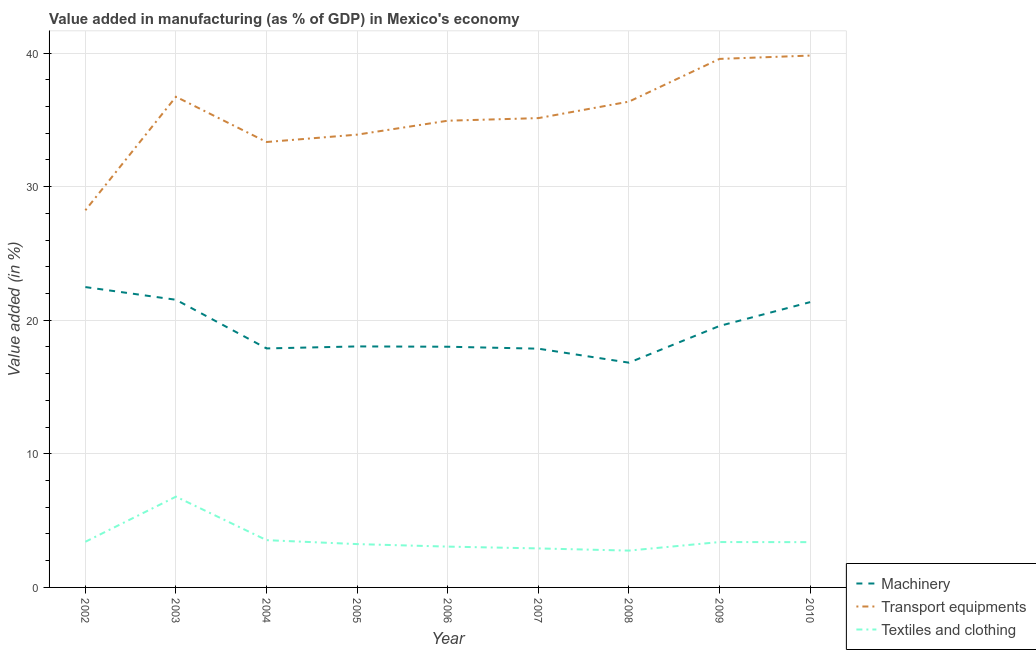How many different coloured lines are there?
Give a very brief answer. 3. What is the value added in manufacturing textile and clothing in 2009?
Give a very brief answer. 3.4. Across all years, what is the maximum value added in manufacturing machinery?
Your answer should be compact. 22.48. Across all years, what is the minimum value added in manufacturing textile and clothing?
Your response must be concise. 2.76. What is the total value added in manufacturing textile and clothing in the graph?
Give a very brief answer. 32.51. What is the difference between the value added in manufacturing transport equipments in 2002 and that in 2009?
Provide a succinct answer. -11.33. What is the difference between the value added in manufacturing transport equipments in 2004 and the value added in manufacturing machinery in 2009?
Offer a very short reply. 13.77. What is the average value added in manufacturing machinery per year?
Give a very brief answer. 19.29. In the year 2007, what is the difference between the value added in manufacturing transport equipments and value added in manufacturing textile and clothing?
Your answer should be compact. 32.21. In how many years, is the value added in manufacturing textile and clothing greater than 28 %?
Offer a very short reply. 0. What is the ratio of the value added in manufacturing machinery in 2005 to that in 2007?
Your answer should be compact. 1.01. Is the value added in manufacturing machinery in 2005 less than that in 2007?
Offer a very short reply. No. Is the difference between the value added in manufacturing machinery in 2003 and 2006 greater than the difference between the value added in manufacturing transport equipments in 2003 and 2006?
Your response must be concise. Yes. What is the difference between the highest and the second highest value added in manufacturing textile and clothing?
Provide a succinct answer. 3.26. What is the difference between the highest and the lowest value added in manufacturing transport equipments?
Make the answer very short. 11.58. Does the value added in manufacturing textile and clothing monotonically increase over the years?
Your answer should be compact. No. Is the value added in manufacturing textile and clothing strictly greater than the value added in manufacturing transport equipments over the years?
Give a very brief answer. No. Is the value added in manufacturing transport equipments strictly less than the value added in manufacturing machinery over the years?
Give a very brief answer. No. How many lines are there?
Offer a very short reply. 3. How many years are there in the graph?
Ensure brevity in your answer.  9. What is the difference between two consecutive major ticks on the Y-axis?
Offer a terse response. 10. Does the graph contain grids?
Your response must be concise. Yes. Where does the legend appear in the graph?
Provide a short and direct response. Bottom right. How are the legend labels stacked?
Your response must be concise. Vertical. What is the title of the graph?
Ensure brevity in your answer.  Value added in manufacturing (as % of GDP) in Mexico's economy. Does "Self-employed" appear as one of the legend labels in the graph?
Provide a short and direct response. No. What is the label or title of the Y-axis?
Your answer should be very brief. Value added (in %). What is the Value added (in %) of Machinery in 2002?
Ensure brevity in your answer.  22.48. What is the Value added (in %) in Transport equipments in 2002?
Your answer should be compact. 28.23. What is the Value added (in %) of Textiles and clothing in 2002?
Offer a terse response. 3.42. What is the Value added (in %) of Machinery in 2003?
Provide a short and direct response. 21.53. What is the Value added (in %) of Transport equipments in 2003?
Offer a very short reply. 36.73. What is the Value added (in %) of Textiles and clothing in 2003?
Your answer should be compact. 6.79. What is the Value added (in %) of Machinery in 2004?
Your answer should be very brief. 17.89. What is the Value added (in %) of Transport equipments in 2004?
Offer a very short reply. 33.34. What is the Value added (in %) in Textiles and clothing in 2004?
Make the answer very short. 3.54. What is the Value added (in %) of Machinery in 2005?
Offer a very short reply. 18.04. What is the Value added (in %) in Transport equipments in 2005?
Your response must be concise. 33.89. What is the Value added (in %) in Textiles and clothing in 2005?
Your response must be concise. 3.24. What is the Value added (in %) of Machinery in 2006?
Offer a terse response. 18.02. What is the Value added (in %) in Transport equipments in 2006?
Make the answer very short. 34.94. What is the Value added (in %) in Textiles and clothing in 2006?
Offer a very short reply. 3.06. What is the Value added (in %) in Machinery in 2007?
Offer a terse response. 17.87. What is the Value added (in %) in Transport equipments in 2007?
Your response must be concise. 35.13. What is the Value added (in %) of Textiles and clothing in 2007?
Provide a short and direct response. 2.92. What is the Value added (in %) in Machinery in 2008?
Offer a very short reply. 16.82. What is the Value added (in %) in Transport equipments in 2008?
Your answer should be very brief. 36.36. What is the Value added (in %) in Textiles and clothing in 2008?
Offer a terse response. 2.76. What is the Value added (in %) of Machinery in 2009?
Provide a short and direct response. 19.57. What is the Value added (in %) of Transport equipments in 2009?
Keep it short and to the point. 39.56. What is the Value added (in %) in Textiles and clothing in 2009?
Your response must be concise. 3.4. What is the Value added (in %) of Machinery in 2010?
Your answer should be compact. 21.36. What is the Value added (in %) of Transport equipments in 2010?
Provide a succinct answer. 39.81. What is the Value added (in %) in Textiles and clothing in 2010?
Provide a short and direct response. 3.39. Across all years, what is the maximum Value added (in %) of Machinery?
Your response must be concise. 22.48. Across all years, what is the maximum Value added (in %) of Transport equipments?
Provide a succinct answer. 39.81. Across all years, what is the maximum Value added (in %) in Textiles and clothing?
Your response must be concise. 6.79. Across all years, what is the minimum Value added (in %) of Machinery?
Provide a short and direct response. 16.82. Across all years, what is the minimum Value added (in %) of Transport equipments?
Provide a short and direct response. 28.23. Across all years, what is the minimum Value added (in %) in Textiles and clothing?
Provide a short and direct response. 2.76. What is the total Value added (in %) in Machinery in the graph?
Offer a terse response. 173.59. What is the total Value added (in %) of Transport equipments in the graph?
Give a very brief answer. 318. What is the total Value added (in %) of Textiles and clothing in the graph?
Your answer should be compact. 32.51. What is the difference between the Value added (in %) in Machinery in 2002 and that in 2003?
Your response must be concise. 0.95. What is the difference between the Value added (in %) of Transport equipments in 2002 and that in 2003?
Make the answer very short. -8.5. What is the difference between the Value added (in %) in Textiles and clothing in 2002 and that in 2003?
Offer a terse response. -3.38. What is the difference between the Value added (in %) of Machinery in 2002 and that in 2004?
Ensure brevity in your answer.  4.59. What is the difference between the Value added (in %) of Transport equipments in 2002 and that in 2004?
Give a very brief answer. -5.11. What is the difference between the Value added (in %) of Textiles and clothing in 2002 and that in 2004?
Give a very brief answer. -0.12. What is the difference between the Value added (in %) of Machinery in 2002 and that in 2005?
Keep it short and to the point. 4.44. What is the difference between the Value added (in %) of Transport equipments in 2002 and that in 2005?
Ensure brevity in your answer.  -5.66. What is the difference between the Value added (in %) in Textiles and clothing in 2002 and that in 2005?
Provide a short and direct response. 0.17. What is the difference between the Value added (in %) in Machinery in 2002 and that in 2006?
Ensure brevity in your answer.  4.47. What is the difference between the Value added (in %) of Transport equipments in 2002 and that in 2006?
Ensure brevity in your answer.  -6.71. What is the difference between the Value added (in %) of Textiles and clothing in 2002 and that in 2006?
Offer a very short reply. 0.36. What is the difference between the Value added (in %) in Machinery in 2002 and that in 2007?
Your answer should be very brief. 4.61. What is the difference between the Value added (in %) in Transport equipments in 2002 and that in 2007?
Your answer should be compact. -6.9. What is the difference between the Value added (in %) in Textiles and clothing in 2002 and that in 2007?
Keep it short and to the point. 0.5. What is the difference between the Value added (in %) in Machinery in 2002 and that in 2008?
Make the answer very short. 5.66. What is the difference between the Value added (in %) of Transport equipments in 2002 and that in 2008?
Provide a succinct answer. -8.13. What is the difference between the Value added (in %) of Textiles and clothing in 2002 and that in 2008?
Make the answer very short. 0.66. What is the difference between the Value added (in %) of Machinery in 2002 and that in 2009?
Keep it short and to the point. 2.91. What is the difference between the Value added (in %) in Transport equipments in 2002 and that in 2009?
Give a very brief answer. -11.33. What is the difference between the Value added (in %) of Textiles and clothing in 2002 and that in 2009?
Provide a short and direct response. 0.02. What is the difference between the Value added (in %) in Machinery in 2002 and that in 2010?
Make the answer very short. 1.13. What is the difference between the Value added (in %) of Transport equipments in 2002 and that in 2010?
Offer a very short reply. -11.58. What is the difference between the Value added (in %) of Textiles and clothing in 2002 and that in 2010?
Make the answer very short. 0.03. What is the difference between the Value added (in %) in Machinery in 2003 and that in 2004?
Provide a succinct answer. 3.64. What is the difference between the Value added (in %) of Transport equipments in 2003 and that in 2004?
Your answer should be very brief. 3.39. What is the difference between the Value added (in %) in Textiles and clothing in 2003 and that in 2004?
Provide a short and direct response. 3.26. What is the difference between the Value added (in %) in Machinery in 2003 and that in 2005?
Your answer should be compact. 3.49. What is the difference between the Value added (in %) of Transport equipments in 2003 and that in 2005?
Your response must be concise. 2.84. What is the difference between the Value added (in %) in Textiles and clothing in 2003 and that in 2005?
Give a very brief answer. 3.55. What is the difference between the Value added (in %) in Machinery in 2003 and that in 2006?
Your answer should be very brief. 3.52. What is the difference between the Value added (in %) of Transport equipments in 2003 and that in 2006?
Keep it short and to the point. 1.79. What is the difference between the Value added (in %) of Textiles and clothing in 2003 and that in 2006?
Keep it short and to the point. 3.74. What is the difference between the Value added (in %) in Machinery in 2003 and that in 2007?
Offer a terse response. 3.66. What is the difference between the Value added (in %) in Transport equipments in 2003 and that in 2007?
Your response must be concise. 1.6. What is the difference between the Value added (in %) in Textiles and clothing in 2003 and that in 2007?
Provide a succinct answer. 3.87. What is the difference between the Value added (in %) in Machinery in 2003 and that in 2008?
Make the answer very short. 4.71. What is the difference between the Value added (in %) of Transport equipments in 2003 and that in 2008?
Make the answer very short. 0.37. What is the difference between the Value added (in %) in Textiles and clothing in 2003 and that in 2008?
Offer a very short reply. 4.04. What is the difference between the Value added (in %) in Machinery in 2003 and that in 2009?
Offer a terse response. 1.96. What is the difference between the Value added (in %) of Transport equipments in 2003 and that in 2009?
Offer a terse response. -2.83. What is the difference between the Value added (in %) of Textiles and clothing in 2003 and that in 2009?
Keep it short and to the point. 3.4. What is the difference between the Value added (in %) of Machinery in 2003 and that in 2010?
Provide a succinct answer. 0.18. What is the difference between the Value added (in %) in Transport equipments in 2003 and that in 2010?
Your answer should be compact. -3.08. What is the difference between the Value added (in %) of Textiles and clothing in 2003 and that in 2010?
Ensure brevity in your answer.  3.4. What is the difference between the Value added (in %) in Machinery in 2004 and that in 2005?
Make the answer very short. -0.15. What is the difference between the Value added (in %) of Transport equipments in 2004 and that in 2005?
Offer a very short reply. -0.55. What is the difference between the Value added (in %) of Textiles and clothing in 2004 and that in 2005?
Keep it short and to the point. 0.3. What is the difference between the Value added (in %) in Machinery in 2004 and that in 2006?
Your response must be concise. -0.13. What is the difference between the Value added (in %) in Transport equipments in 2004 and that in 2006?
Provide a succinct answer. -1.59. What is the difference between the Value added (in %) in Textiles and clothing in 2004 and that in 2006?
Provide a succinct answer. 0.48. What is the difference between the Value added (in %) in Machinery in 2004 and that in 2007?
Your answer should be compact. 0.02. What is the difference between the Value added (in %) of Transport equipments in 2004 and that in 2007?
Your answer should be very brief. -1.79. What is the difference between the Value added (in %) in Textiles and clothing in 2004 and that in 2007?
Offer a terse response. 0.62. What is the difference between the Value added (in %) in Machinery in 2004 and that in 2008?
Provide a short and direct response. 1.07. What is the difference between the Value added (in %) of Transport equipments in 2004 and that in 2008?
Your answer should be very brief. -3.02. What is the difference between the Value added (in %) in Textiles and clothing in 2004 and that in 2008?
Provide a short and direct response. 0.78. What is the difference between the Value added (in %) of Machinery in 2004 and that in 2009?
Provide a succinct answer. -1.68. What is the difference between the Value added (in %) of Transport equipments in 2004 and that in 2009?
Keep it short and to the point. -6.22. What is the difference between the Value added (in %) of Textiles and clothing in 2004 and that in 2009?
Provide a short and direct response. 0.14. What is the difference between the Value added (in %) in Machinery in 2004 and that in 2010?
Give a very brief answer. -3.47. What is the difference between the Value added (in %) of Transport equipments in 2004 and that in 2010?
Your answer should be compact. -6.47. What is the difference between the Value added (in %) in Textiles and clothing in 2004 and that in 2010?
Offer a terse response. 0.15. What is the difference between the Value added (in %) in Machinery in 2005 and that in 2006?
Keep it short and to the point. 0.02. What is the difference between the Value added (in %) in Transport equipments in 2005 and that in 2006?
Your response must be concise. -1.04. What is the difference between the Value added (in %) in Textiles and clothing in 2005 and that in 2006?
Offer a terse response. 0.19. What is the difference between the Value added (in %) in Machinery in 2005 and that in 2007?
Ensure brevity in your answer.  0.17. What is the difference between the Value added (in %) in Transport equipments in 2005 and that in 2007?
Provide a succinct answer. -1.24. What is the difference between the Value added (in %) of Textiles and clothing in 2005 and that in 2007?
Keep it short and to the point. 0.32. What is the difference between the Value added (in %) in Machinery in 2005 and that in 2008?
Offer a very short reply. 1.22. What is the difference between the Value added (in %) of Transport equipments in 2005 and that in 2008?
Ensure brevity in your answer.  -2.47. What is the difference between the Value added (in %) in Textiles and clothing in 2005 and that in 2008?
Provide a succinct answer. 0.49. What is the difference between the Value added (in %) in Machinery in 2005 and that in 2009?
Provide a succinct answer. -1.53. What is the difference between the Value added (in %) in Transport equipments in 2005 and that in 2009?
Keep it short and to the point. -5.67. What is the difference between the Value added (in %) in Textiles and clothing in 2005 and that in 2009?
Ensure brevity in your answer.  -0.15. What is the difference between the Value added (in %) of Machinery in 2005 and that in 2010?
Offer a terse response. -3.32. What is the difference between the Value added (in %) of Transport equipments in 2005 and that in 2010?
Provide a short and direct response. -5.92. What is the difference between the Value added (in %) in Textiles and clothing in 2005 and that in 2010?
Keep it short and to the point. -0.15. What is the difference between the Value added (in %) in Machinery in 2006 and that in 2007?
Provide a succinct answer. 0.15. What is the difference between the Value added (in %) in Transport equipments in 2006 and that in 2007?
Your answer should be very brief. -0.2. What is the difference between the Value added (in %) in Textiles and clothing in 2006 and that in 2007?
Your answer should be very brief. 0.14. What is the difference between the Value added (in %) in Machinery in 2006 and that in 2008?
Provide a short and direct response. 1.19. What is the difference between the Value added (in %) in Transport equipments in 2006 and that in 2008?
Provide a short and direct response. -1.43. What is the difference between the Value added (in %) of Textiles and clothing in 2006 and that in 2008?
Your response must be concise. 0.3. What is the difference between the Value added (in %) in Machinery in 2006 and that in 2009?
Your response must be concise. -1.56. What is the difference between the Value added (in %) in Transport equipments in 2006 and that in 2009?
Your answer should be very brief. -4.63. What is the difference between the Value added (in %) of Textiles and clothing in 2006 and that in 2009?
Offer a terse response. -0.34. What is the difference between the Value added (in %) of Machinery in 2006 and that in 2010?
Offer a very short reply. -3.34. What is the difference between the Value added (in %) in Transport equipments in 2006 and that in 2010?
Make the answer very short. -4.88. What is the difference between the Value added (in %) in Textiles and clothing in 2006 and that in 2010?
Provide a succinct answer. -0.33. What is the difference between the Value added (in %) in Machinery in 2007 and that in 2008?
Keep it short and to the point. 1.05. What is the difference between the Value added (in %) of Transport equipments in 2007 and that in 2008?
Offer a very short reply. -1.23. What is the difference between the Value added (in %) of Textiles and clothing in 2007 and that in 2008?
Make the answer very short. 0.16. What is the difference between the Value added (in %) in Machinery in 2007 and that in 2009?
Keep it short and to the point. -1.7. What is the difference between the Value added (in %) in Transport equipments in 2007 and that in 2009?
Your answer should be very brief. -4.43. What is the difference between the Value added (in %) of Textiles and clothing in 2007 and that in 2009?
Offer a terse response. -0.48. What is the difference between the Value added (in %) of Machinery in 2007 and that in 2010?
Your answer should be very brief. -3.48. What is the difference between the Value added (in %) in Transport equipments in 2007 and that in 2010?
Ensure brevity in your answer.  -4.68. What is the difference between the Value added (in %) in Textiles and clothing in 2007 and that in 2010?
Provide a short and direct response. -0.47. What is the difference between the Value added (in %) of Machinery in 2008 and that in 2009?
Make the answer very short. -2.75. What is the difference between the Value added (in %) in Transport equipments in 2008 and that in 2009?
Ensure brevity in your answer.  -3.2. What is the difference between the Value added (in %) of Textiles and clothing in 2008 and that in 2009?
Make the answer very short. -0.64. What is the difference between the Value added (in %) of Machinery in 2008 and that in 2010?
Offer a terse response. -4.53. What is the difference between the Value added (in %) in Transport equipments in 2008 and that in 2010?
Provide a succinct answer. -3.45. What is the difference between the Value added (in %) of Textiles and clothing in 2008 and that in 2010?
Your answer should be compact. -0.63. What is the difference between the Value added (in %) of Machinery in 2009 and that in 2010?
Provide a short and direct response. -1.78. What is the difference between the Value added (in %) in Transport equipments in 2009 and that in 2010?
Offer a very short reply. -0.25. What is the difference between the Value added (in %) of Textiles and clothing in 2009 and that in 2010?
Ensure brevity in your answer.  0.01. What is the difference between the Value added (in %) in Machinery in 2002 and the Value added (in %) in Transport equipments in 2003?
Provide a succinct answer. -14.25. What is the difference between the Value added (in %) in Machinery in 2002 and the Value added (in %) in Textiles and clothing in 2003?
Provide a short and direct response. 15.69. What is the difference between the Value added (in %) in Transport equipments in 2002 and the Value added (in %) in Textiles and clothing in 2003?
Your answer should be compact. 21.44. What is the difference between the Value added (in %) of Machinery in 2002 and the Value added (in %) of Transport equipments in 2004?
Keep it short and to the point. -10.86. What is the difference between the Value added (in %) of Machinery in 2002 and the Value added (in %) of Textiles and clothing in 2004?
Ensure brevity in your answer.  18.94. What is the difference between the Value added (in %) of Transport equipments in 2002 and the Value added (in %) of Textiles and clothing in 2004?
Make the answer very short. 24.69. What is the difference between the Value added (in %) of Machinery in 2002 and the Value added (in %) of Transport equipments in 2005?
Make the answer very short. -11.41. What is the difference between the Value added (in %) of Machinery in 2002 and the Value added (in %) of Textiles and clothing in 2005?
Give a very brief answer. 19.24. What is the difference between the Value added (in %) of Transport equipments in 2002 and the Value added (in %) of Textiles and clothing in 2005?
Provide a succinct answer. 24.99. What is the difference between the Value added (in %) of Machinery in 2002 and the Value added (in %) of Transport equipments in 2006?
Keep it short and to the point. -12.45. What is the difference between the Value added (in %) of Machinery in 2002 and the Value added (in %) of Textiles and clothing in 2006?
Your answer should be compact. 19.43. What is the difference between the Value added (in %) in Transport equipments in 2002 and the Value added (in %) in Textiles and clothing in 2006?
Provide a succinct answer. 25.18. What is the difference between the Value added (in %) in Machinery in 2002 and the Value added (in %) in Transport equipments in 2007?
Offer a terse response. -12.65. What is the difference between the Value added (in %) in Machinery in 2002 and the Value added (in %) in Textiles and clothing in 2007?
Keep it short and to the point. 19.56. What is the difference between the Value added (in %) in Transport equipments in 2002 and the Value added (in %) in Textiles and clothing in 2007?
Make the answer very short. 25.31. What is the difference between the Value added (in %) in Machinery in 2002 and the Value added (in %) in Transport equipments in 2008?
Keep it short and to the point. -13.88. What is the difference between the Value added (in %) in Machinery in 2002 and the Value added (in %) in Textiles and clothing in 2008?
Offer a very short reply. 19.73. What is the difference between the Value added (in %) in Transport equipments in 2002 and the Value added (in %) in Textiles and clothing in 2008?
Your answer should be compact. 25.47. What is the difference between the Value added (in %) in Machinery in 2002 and the Value added (in %) in Transport equipments in 2009?
Your answer should be very brief. -17.08. What is the difference between the Value added (in %) in Machinery in 2002 and the Value added (in %) in Textiles and clothing in 2009?
Make the answer very short. 19.09. What is the difference between the Value added (in %) of Transport equipments in 2002 and the Value added (in %) of Textiles and clothing in 2009?
Give a very brief answer. 24.83. What is the difference between the Value added (in %) in Machinery in 2002 and the Value added (in %) in Transport equipments in 2010?
Your answer should be very brief. -17.33. What is the difference between the Value added (in %) of Machinery in 2002 and the Value added (in %) of Textiles and clothing in 2010?
Keep it short and to the point. 19.09. What is the difference between the Value added (in %) in Transport equipments in 2002 and the Value added (in %) in Textiles and clothing in 2010?
Your answer should be compact. 24.84. What is the difference between the Value added (in %) of Machinery in 2003 and the Value added (in %) of Transport equipments in 2004?
Keep it short and to the point. -11.81. What is the difference between the Value added (in %) in Machinery in 2003 and the Value added (in %) in Textiles and clothing in 2004?
Ensure brevity in your answer.  17.99. What is the difference between the Value added (in %) of Transport equipments in 2003 and the Value added (in %) of Textiles and clothing in 2004?
Provide a short and direct response. 33.19. What is the difference between the Value added (in %) of Machinery in 2003 and the Value added (in %) of Transport equipments in 2005?
Your answer should be compact. -12.36. What is the difference between the Value added (in %) of Machinery in 2003 and the Value added (in %) of Textiles and clothing in 2005?
Keep it short and to the point. 18.29. What is the difference between the Value added (in %) in Transport equipments in 2003 and the Value added (in %) in Textiles and clothing in 2005?
Offer a terse response. 33.49. What is the difference between the Value added (in %) in Machinery in 2003 and the Value added (in %) in Transport equipments in 2006?
Offer a very short reply. -13.4. What is the difference between the Value added (in %) of Machinery in 2003 and the Value added (in %) of Textiles and clothing in 2006?
Give a very brief answer. 18.48. What is the difference between the Value added (in %) of Transport equipments in 2003 and the Value added (in %) of Textiles and clothing in 2006?
Ensure brevity in your answer.  33.67. What is the difference between the Value added (in %) of Machinery in 2003 and the Value added (in %) of Transport equipments in 2007?
Offer a very short reply. -13.6. What is the difference between the Value added (in %) of Machinery in 2003 and the Value added (in %) of Textiles and clothing in 2007?
Provide a succinct answer. 18.61. What is the difference between the Value added (in %) in Transport equipments in 2003 and the Value added (in %) in Textiles and clothing in 2007?
Your answer should be very brief. 33.81. What is the difference between the Value added (in %) of Machinery in 2003 and the Value added (in %) of Transport equipments in 2008?
Your answer should be very brief. -14.83. What is the difference between the Value added (in %) in Machinery in 2003 and the Value added (in %) in Textiles and clothing in 2008?
Ensure brevity in your answer.  18.78. What is the difference between the Value added (in %) in Transport equipments in 2003 and the Value added (in %) in Textiles and clothing in 2008?
Give a very brief answer. 33.97. What is the difference between the Value added (in %) of Machinery in 2003 and the Value added (in %) of Transport equipments in 2009?
Make the answer very short. -18.03. What is the difference between the Value added (in %) of Machinery in 2003 and the Value added (in %) of Textiles and clothing in 2009?
Your answer should be compact. 18.14. What is the difference between the Value added (in %) in Transport equipments in 2003 and the Value added (in %) in Textiles and clothing in 2009?
Provide a succinct answer. 33.33. What is the difference between the Value added (in %) in Machinery in 2003 and the Value added (in %) in Transport equipments in 2010?
Keep it short and to the point. -18.28. What is the difference between the Value added (in %) in Machinery in 2003 and the Value added (in %) in Textiles and clothing in 2010?
Your answer should be very brief. 18.14. What is the difference between the Value added (in %) in Transport equipments in 2003 and the Value added (in %) in Textiles and clothing in 2010?
Give a very brief answer. 33.34. What is the difference between the Value added (in %) in Machinery in 2004 and the Value added (in %) in Transport equipments in 2005?
Your answer should be compact. -16. What is the difference between the Value added (in %) of Machinery in 2004 and the Value added (in %) of Textiles and clothing in 2005?
Give a very brief answer. 14.65. What is the difference between the Value added (in %) in Transport equipments in 2004 and the Value added (in %) in Textiles and clothing in 2005?
Keep it short and to the point. 30.1. What is the difference between the Value added (in %) in Machinery in 2004 and the Value added (in %) in Transport equipments in 2006?
Your response must be concise. -17.05. What is the difference between the Value added (in %) in Machinery in 2004 and the Value added (in %) in Textiles and clothing in 2006?
Offer a terse response. 14.83. What is the difference between the Value added (in %) in Transport equipments in 2004 and the Value added (in %) in Textiles and clothing in 2006?
Provide a succinct answer. 30.29. What is the difference between the Value added (in %) of Machinery in 2004 and the Value added (in %) of Transport equipments in 2007?
Make the answer very short. -17.24. What is the difference between the Value added (in %) in Machinery in 2004 and the Value added (in %) in Textiles and clothing in 2007?
Your answer should be very brief. 14.97. What is the difference between the Value added (in %) in Transport equipments in 2004 and the Value added (in %) in Textiles and clothing in 2007?
Keep it short and to the point. 30.42. What is the difference between the Value added (in %) of Machinery in 2004 and the Value added (in %) of Transport equipments in 2008?
Your response must be concise. -18.47. What is the difference between the Value added (in %) of Machinery in 2004 and the Value added (in %) of Textiles and clothing in 2008?
Keep it short and to the point. 15.13. What is the difference between the Value added (in %) in Transport equipments in 2004 and the Value added (in %) in Textiles and clothing in 2008?
Make the answer very short. 30.59. What is the difference between the Value added (in %) of Machinery in 2004 and the Value added (in %) of Transport equipments in 2009?
Give a very brief answer. -21.67. What is the difference between the Value added (in %) in Machinery in 2004 and the Value added (in %) in Textiles and clothing in 2009?
Ensure brevity in your answer.  14.49. What is the difference between the Value added (in %) in Transport equipments in 2004 and the Value added (in %) in Textiles and clothing in 2009?
Your response must be concise. 29.95. What is the difference between the Value added (in %) of Machinery in 2004 and the Value added (in %) of Transport equipments in 2010?
Ensure brevity in your answer.  -21.92. What is the difference between the Value added (in %) in Machinery in 2004 and the Value added (in %) in Textiles and clothing in 2010?
Provide a short and direct response. 14.5. What is the difference between the Value added (in %) of Transport equipments in 2004 and the Value added (in %) of Textiles and clothing in 2010?
Offer a very short reply. 29.95. What is the difference between the Value added (in %) in Machinery in 2005 and the Value added (in %) in Transport equipments in 2006?
Your response must be concise. -16.9. What is the difference between the Value added (in %) in Machinery in 2005 and the Value added (in %) in Textiles and clothing in 2006?
Offer a terse response. 14.99. What is the difference between the Value added (in %) of Transport equipments in 2005 and the Value added (in %) of Textiles and clothing in 2006?
Your response must be concise. 30.84. What is the difference between the Value added (in %) in Machinery in 2005 and the Value added (in %) in Transport equipments in 2007?
Your answer should be compact. -17.09. What is the difference between the Value added (in %) of Machinery in 2005 and the Value added (in %) of Textiles and clothing in 2007?
Ensure brevity in your answer.  15.12. What is the difference between the Value added (in %) in Transport equipments in 2005 and the Value added (in %) in Textiles and clothing in 2007?
Provide a succinct answer. 30.97. What is the difference between the Value added (in %) of Machinery in 2005 and the Value added (in %) of Transport equipments in 2008?
Your answer should be very brief. -18.32. What is the difference between the Value added (in %) of Machinery in 2005 and the Value added (in %) of Textiles and clothing in 2008?
Your response must be concise. 15.28. What is the difference between the Value added (in %) of Transport equipments in 2005 and the Value added (in %) of Textiles and clothing in 2008?
Offer a terse response. 31.14. What is the difference between the Value added (in %) of Machinery in 2005 and the Value added (in %) of Transport equipments in 2009?
Keep it short and to the point. -21.52. What is the difference between the Value added (in %) of Machinery in 2005 and the Value added (in %) of Textiles and clothing in 2009?
Ensure brevity in your answer.  14.64. What is the difference between the Value added (in %) of Transport equipments in 2005 and the Value added (in %) of Textiles and clothing in 2009?
Give a very brief answer. 30.5. What is the difference between the Value added (in %) of Machinery in 2005 and the Value added (in %) of Transport equipments in 2010?
Your response must be concise. -21.77. What is the difference between the Value added (in %) in Machinery in 2005 and the Value added (in %) in Textiles and clothing in 2010?
Make the answer very short. 14.65. What is the difference between the Value added (in %) of Transport equipments in 2005 and the Value added (in %) of Textiles and clothing in 2010?
Your answer should be very brief. 30.5. What is the difference between the Value added (in %) in Machinery in 2006 and the Value added (in %) in Transport equipments in 2007?
Your answer should be compact. -17.11. What is the difference between the Value added (in %) of Machinery in 2006 and the Value added (in %) of Textiles and clothing in 2007?
Make the answer very short. 15.1. What is the difference between the Value added (in %) of Transport equipments in 2006 and the Value added (in %) of Textiles and clothing in 2007?
Your response must be concise. 32.02. What is the difference between the Value added (in %) in Machinery in 2006 and the Value added (in %) in Transport equipments in 2008?
Make the answer very short. -18.35. What is the difference between the Value added (in %) of Machinery in 2006 and the Value added (in %) of Textiles and clothing in 2008?
Ensure brevity in your answer.  15.26. What is the difference between the Value added (in %) in Transport equipments in 2006 and the Value added (in %) in Textiles and clothing in 2008?
Give a very brief answer. 32.18. What is the difference between the Value added (in %) of Machinery in 2006 and the Value added (in %) of Transport equipments in 2009?
Keep it short and to the point. -21.55. What is the difference between the Value added (in %) in Machinery in 2006 and the Value added (in %) in Textiles and clothing in 2009?
Provide a succinct answer. 14.62. What is the difference between the Value added (in %) in Transport equipments in 2006 and the Value added (in %) in Textiles and clothing in 2009?
Give a very brief answer. 31.54. What is the difference between the Value added (in %) in Machinery in 2006 and the Value added (in %) in Transport equipments in 2010?
Offer a very short reply. -21.79. What is the difference between the Value added (in %) of Machinery in 2006 and the Value added (in %) of Textiles and clothing in 2010?
Your response must be concise. 14.63. What is the difference between the Value added (in %) in Transport equipments in 2006 and the Value added (in %) in Textiles and clothing in 2010?
Provide a succinct answer. 31.55. What is the difference between the Value added (in %) of Machinery in 2007 and the Value added (in %) of Transport equipments in 2008?
Make the answer very short. -18.49. What is the difference between the Value added (in %) of Machinery in 2007 and the Value added (in %) of Textiles and clothing in 2008?
Offer a terse response. 15.12. What is the difference between the Value added (in %) in Transport equipments in 2007 and the Value added (in %) in Textiles and clothing in 2008?
Keep it short and to the point. 32.37. What is the difference between the Value added (in %) in Machinery in 2007 and the Value added (in %) in Transport equipments in 2009?
Offer a very short reply. -21.69. What is the difference between the Value added (in %) in Machinery in 2007 and the Value added (in %) in Textiles and clothing in 2009?
Your answer should be very brief. 14.48. What is the difference between the Value added (in %) in Transport equipments in 2007 and the Value added (in %) in Textiles and clothing in 2009?
Provide a succinct answer. 31.73. What is the difference between the Value added (in %) of Machinery in 2007 and the Value added (in %) of Transport equipments in 2010?
Provide a succinct answer. -21.94. What is the difference between the Value added (in %) of Machinery in 2007 and the Value added (in %) of Textiles and clothing in 2010?
Your answer should be very brief. 14.48. What is the difference between the Value added (in %) of Transport equipments in 2007 and the Value added (in %) of Textiles and clothing in 2010?
Your answer should be compact. 31.74. What is the difference between the Value added (in %) in Machinery in 2008 and the Value added (in %) in Transport equipments in 2009?
Offer a terse response. -22.74. What is the difference between the Value added (in %) of Machinery in 2008 and the Value added (in %) of Textiles and clothing in 2009?
Your answer should be very brief. 13.43. What is the difference between the Value added (in %) in Transport equipments in 2008 and the Value added (in %) in Textiles and clothing in 2009?
Ensure brevity in your answer.  32.97. What is the difference between the Value added (in %) of Machinery in 2008 and the Value added (in %) of Transport equipments in 2010?
Give a very brief answer. -22.99. What is the difference between the Value added (in %) in Machinery in 2008 and the Value added (in %) in Textiles and clothing in 2010?
Your response must be concise. 13.43. What is the difference between the Value added (in %) of Transport equipments in 2008 and the Value added (in %) of Textiles and clothing in 2010?
Ensure brevity in your answer.  32.97. What is the difference between the Value added (in %) in Machinery in 2009 and the Value added (in %) in Transport equipments in 2010?
Your answer should be compact. -20.24. What is the difference between the Value added (in %) in Machinery in 2009 and the Value added (in %) in Textiles and clothing in 2010?
Give a very brief answer. 16.18. What is the difference between the Value added (in %) in Transport equipments in 2009 and the Value added (in %) in Textiles and clothing in 2010?
Offer a terse response. 36.17. What is the average Value added (in %) in Machinery per year?
Your answer should be compact. 19.29. What is the average Value added (in %) in Transport equipments per year?
Your answer should be compact. 35.33. What is the average Value added (in %) of Textiles and clothing per year?
Provide a succinct answer. 3.61. In the year 2002, what is the difference between the Value added (in %) in Machinery and Value added (in %) in Transport equipments?
Provide a succinct answer. -5.75. In the year 2002, what is the difference between the Value added (in %) of Machinery and Value added (in %) of Textiles and clothing?
Make the answer very short. 19.07. In the year 2002, what is the difference between the Value added (in %) of Transport equipments and Value added (in %) of Textiles and clothing?
Your response must be concise. 24.81. In the year 2003, what is the difference between the Value added (in %) of Machinery and Value added (in %) of Transport equipments?
Offer a very short reply. -15.2. In the year 2003, what is the difference between the Value added (in %) in Machinery and Value added (in %) in Textiles and clothing?
Offer a very short reply. 14.74. In the year 2003, what is the difference between the Value added (in %) of Transport equipments and Value added (in %) of Textiles and clothing?
Make the answer very short. 29.93. In the year 2004, what is the difference between the Value added (in %) of Machinery and Value added (in %) of Transport equipments?
Provide a succinct answer. -15.45. In the year 2004, what is the difference between the Value added (in %) of Machinery and Value added (in %) of Textiles and clothing?
Offer a terse response. 14.35. In the year 2004, what is the difference between the Value added (in %) of Transport equipments and Value added (in %) of Textiles and clothing?
Provide a succinct answer. 29.8. In the year 2005, what is the difference between the Value added (in %) of Machinery and Value added (in %) of Transport equipments?
Your response must be concise. -15.85. In the year 2005, what is the difference between the Value added (in %) in Machinery and Value added (in %) in Textiles and clothing?
Provide a short and direct response. 14.8. In the year 2005, what is the difference between the Value added (in %) in Transport equipments and Value added (in %) in Textiles and clothing?
Offer a terse response. 30.65. In the year 2006, what is the difference between the Value added (in %) of Machinery and Value added (in %) of Transport equipments?
Provide a short and direct response. -16.92. In the year 2006, what is the difference between the Value added (in %) of Machinery and Value added (in %) of Textiles and clothing?
Offer a very short reply. 14.96. In the year 2006, what is the difference between the Value added (in %) in Transport equipments and Value added (in %) in Textiles and clothing?
Your answer should be compact. 31.88. In the year 2007, what is the difference between the Value added (in %) of Machinery and Value added (in %) of Transport equipments?
Offer a very short reply. -17.26. In the year 2007, what is the difference between the Value added (in %) of Machinery and Value added (in %) of Textiles and clothing?
Your answer should be very brief. 14.95. In the year 2007, what is the difference between the Value added (in %) in Transport equipments and Value added (in %) in Textiles and clothing?
Offer a very short reply. 32.21. In the year 2008, what is the difference between the Value added (in %) in Machinery and Value added (in %) in Transport equipments?
Your response must be concise. -19.54. In the year 2008, what is the difference between the Value added (in %) in Machinery and Value added (in %) in Textiles and clothing?
Keep it short and to the point. 14.07. In the year 2008, what is the difference between the Value added (in %) in Transport equipments and Value added (in %) in Textiles and clothing?
Make the answer very short. 33.61. In the year 2009, what is the difference between the Value added (in %) of Machinery and Value added (in %) of Transport equipments?
Your answer should be very brief. -19.99. In the year 2009, what is the difference between the Value added (in %) of Machinery and Value added (in %) of Textiles and clothing?
Your answer should be compact. 16.18. In the year 2009, what is the difference between the Value added (in %) of Transport equipments and Value added (in %) of Textiles and clothing?
Give a very brief answer. 36.17. In the year 2010, what is the difference between the Value added (in %) in Machinery and Value added (in %) in Transport equipments?
Make the answer very short. -18.46. In the year 2010, what is the difference between the Value added (in %) of Machinery and Value added (in %) of Textiles and clothing?
Offer a very short reply. 17.97. In the year 2010, what is the difference between the Value added (in %) in Transport equipments and Value added (in %) in Textiles and clothing?
Provide a succinct answer. 36.42. What is the ratio of the Value added (in %) of Machinery in 2002 to that in 2003?
Provide a short and direct response. 1.04. What is the ratio of the Value added (in %) of Transport equipments in 2002 to that in 2003?
Ensure brevity in your answer.  0.77. What is the ratio of the Value added (in %) of Textiles and clothing in 2002 to that in 2003?
Ensure brevity in your answer.  0.5. What is the ratio of the Value added (in %) in Machinery in 2002 to that in 2004?
Make the answer very short. 1.26. What is the ratio of the Value added (in %) of Transport equipments in 2002 to that in 2004?
Offer a very short reply. 0.85. What is the ratio of the Value added (in %) of Textiles and clothing in 2002 to that in 2004?
Your response must be concise. 0.97. What is the ratio of the Value added (in %) in Machinery in 2002 to that in 2005?
Your answer should be compact. 1.25. What is the ratio of the Value added (in %) in Transport equipments in 2002 to that in 2005?
Offer a very short reply. 0.83. What is the ratio of the Value added (in %) in Textiles and clothing in 2002 to that in 2005?
Give a very brief answer. 1.05. What is the ratio of the Value added (in %) of Machinery in 2002 to that in 2006?
Provide a short and direct response. 1.25. What is the ratio of the Value added (in %) in Transport equipments in 2002 to that in 2006?
Keep it short and to the point. 0.81. What is the ratio of the Value added (in %) of Textiles and clothing in 2002 to that in 2006?
Keep it short and to the point. 1.12. What is the ratio of the Value added (in %) of Machinery in 2002 to that in 2007?
Ensure brevity in your answer.  1.26. What is the ratio of the Value added (in %) in Transport equipments in 2002 to that in 2007?
Provide a succinct answer. 0.8. What is the ratio of the Value added (in %) in Textiles and clothing in 2002 to that in 2007?
Offer a very short reply. 1.17. What is the ratio of the Value added (in %) of Machinery in 2002 to that in 2008?
Ensure brevity in your answer.  1.34. What is the ratio of the Value added (in %) in Transport equipments in 2002 to that in 2008?
Make the answer very short. 0.78. What is the ratio of the Value added (in %) of Textiles and clothing in 2002 to that in 2008?
Your response must be concise. 1.24. What is the ratio of the Value added (in %) of Machinery in 2002 to that in 2009?
Your answer should be compact. 1.15. What is the ratio of the Value added (in %) in Transport equipments in 2002 to that in 2009?
Offer a terse response. 0.71. What is the ratio of the Value added (in %) of Textiles and clothing in 2002 to that in 2009?
Give a very brief answer. 1.01. What is the ratio of the Value added (in %) of Machinery in 2002 to that in 2010?
Your response must be concise. 1.05. What is the ratio of the Value added (in %) of Transport equipments in 2002 to that in 2010?
Your response must be concise. 0.71. What is the ratio of the Value added (in %) in Textiles and clothing in 2002 to that in 2010?
Ensure brevity in your answer.  1.01. What is the ratio of the Value added (in %) in Machinery in 2003 to that in 2004?
Provide a short and direct response. 1.2. What is the ratio of the Value added (in %) of Transport equipments in 2003 to that in 2004?
Give a very brief answer. 1.1. What is the ratio of the Value added (in %) of Textiles and clothing in 2003 to that in 2004?
Your answer should be compact. 1.92. What is the ratio of the Value added (in %) of Machinery in 2003 to that in 2005?
Provide a succinct answer. 1.19. What is the ratio of the Value added (in %) of Transport equipments in 2003 to that in 2005?
Your response must be concise. 1.08. What is the ratio of the Value added (in %) of Textiles and clothing in 2003 to that in 2005?
Ensure brevity in your answer.  2.1. What is the ratio of the Value added (in %) of Machinery in 2003 to that in 2006?
Provide a short and direct response. 1.2. What is the ratio of the Value added (in %) of Transport equipments in 2003 to that in 2006?
Provide a succinct answer. 1.05. What is the ratio of the Value added (in %) in Textiles and clothing in 2003 to that in 2006?
Keep it short and to the point. 2.22. What is the ratio of the Value added (in %) of Machinery in 2003 to that in 2007?
Provide a succinct answer. 1.2. What is the ratio of the Value added (in %) of Transport equipments in 2003 to that in 2007?
Your answer should be very brief. 1.05. What is the ratio of the Value added (in %) in Textiles and clothing in 2003 to that in 2007?
Offer a very short reply. 2.33. What is the ratio of the Value added (in %) of Machinery in 2003 to that in 2008?
Offer a terse response. 1.28. What is the ratio of the Value added (in %) of Textiles and clothing in 2003 to that in 2008?
Offer a very short reply. 2.47. What is the ratio of the Value added (in %) in Machinery in 2003 to that in 2009?
Provide a succinct answer. 1.1. What is the ratio of the Value added (in %) of Transport equipments in 2003 to that in 2009?
Ensure brevity in your answer.  0.93. What is the ratio of the Value added (in %) of Textiles and clothing in 2003 to that in 2009?
Provide a succinct answer. 2. What is the ratio of the Value added (in %) in Machinery in 2003 to that in 2010?
Give a very brief answer. 1.01. What is the ratio of the Value added (in %) in Transport equipments in 2003 to that in 2010?
Provide a short and direct response. 0.92. What is the ratio of the Value added (in %) in Textiles and clothing in 2003 to that in 2010?
Keep it short and to the point. 2. What is the ratio of the Value added (in %) in Transport equipments in 2004 to that in 2005?
Offer a terse response. 0.98. What is the ratio of the Value added (in %) of Textiles and clothing in 2004 to that in 2005?
Make the answer very short. 1.09. What is the ratio of the Value added (in %) of Transport equipments in 2004 to that in 2006?
Offer a terse response. 0.95. What is the ratio of the Value added (in %) of Textiles and clothing in 2004 to that in 2006?
Keep it short and to the point. 1.16. What is the ratio of the Value added (in %) of Machinery in 2004 to that in 2007?
Make the answer very short. 1. What is the ratio of the Value added (in %) in Transport equipments in 2004 to that in 2007?
Keep it short and to the point. 0.95. What is the ratio of the Value added (in %) of Textiles and clothing in 2004 to that in 2007?
Ensure brevity in your answer.  1.21. What is the ratio of the Value added (in %) of Machinery in 2004 to that in 2008?
Provide a succinct answer. 1.06. What is the ratio of the Value added (in %) in Transport equipments in 2004 to that in 2008?
Give a very brief answer. 0.92. What is the ratio of the Value added (in %) of Textiles and clothing in 2004 to that in 2008?
Provide a short and direct response. 1.28. What is the ratio of the Value added (in %) in Machinery in 2004 to that in 2009?
Provide a succinct answer. 0.91. What is the ratio of the Value added (in %) of Transport equipments in 2004 to that in 2009?
Keep it short and to the point. 0.84. What is the ratio of the Value added (in %) of Textiles and clothing in 2004 to that in 2009?
Provide a short and direct response. 1.04. What is the ratio of the Value added (in %) in Machinery in 2004 to that in 2010?
Your answer should be very brief. 0.84. What is the ratio of the Value added (in %) in Transport equipments in 2004 to that in 2010?
Make the answer very short. 0.84. What is the ratio of the Value added (in %) in Textiles and clothing in 2004 to that in 2010?
Offer a terse response. 1.04. What is the ratio of the Value added (in %) of Transport equipments in 2005 to that in 2006?
Keep it short and to the point. 0.97. What is the ratio of the Value added (in %) in Textiles and clothing in 2005 to that in 2006?
Keep it short and to the point. 1.06. What is the ratio of the Value added (in %) of Machinery in 2005 to that in 2007?
Your response must be concise. 1.01. What is the ratio of the Value added (in %) in Transport equipments in 2005 to that in 2007?
Ensure brevity in your answer.  0.96. What is the ratio of the Value added (in %) of Textiles and clothing in 2005 to that in 2007?
Provide a short and direct response. 1.11. What is the ratio of the Value added (in %) in Machinery in 2005 to that in 2008?
Provide a short and direct response. 1.07. What is the ratio of the Value added (in %) of Transport equipments in 2005 to that in 2008?
Give a very brief answer. 0.93. What is the ratio of the Value added (in %) in Textiles and clothing in 2005 to that in 2008?
Offer a terse response. 1.18. What is the ratio of the Value added (in %) in Machinery in 2005 to that in 2009?
Provide a short and direct response. 0.92. What is the ratio of the Value added (in %) in Transport equipments in 2005 to that in 2009?
Offer a very short reply. 0.86. What is the ratio of the Value added (in %) of Textiles and clothing in 2005 to that in 2009?
Offer a terse response. 0.95. What is the ratio of the Value added (in %) of Machinery in 2005 to that in 2010?
Ensure brevity in your answer.  0.84. What is the ratio of the Value added (in %) of Transport equipments in 2005 to that in 2010?
Offer a terse response. 0.85. What is the ratio of the Value added (in %) in Textiles and clothing in 2005 to that in 2010?
Your answer should be very brief. 0.96. What is the ratio of the Value added (in %) of Machinery in 2006 to that in 2007?
Give a very brief answer. 1.01. What is the ratio of the Value added (in %) of Transport equipments in 2006 to that in 2007?
Your response must be concise. 0.99. What is the ratio of the Value added (in %) in Textiles and clothing in 2006 to that in 2007?
Your answer should be very brief. 1.05. What is the ratio of the Value added (in %) of Machinery in 2006 to that in 2008?
Ensure brevity in your answer.  1.07. What is the ratio of the Value added (in %) of Transport equipments in 2006 to that in 2008?
Give a very brief answer. 0.96. What is the ratio of the Value added (in %) of Textiles and clothing in 2006 to that in 2008?
Keep it short and to the point. 1.11. What is the ratio of the Value added (in %) in Machinery in 2006 to that in 2009?
Provide a succinct answer. 0.92. What is the ratio of the Value added (in %) in Transport equipments in 2006 to that in 2009?
Offer a very short reply. 0.88. What is the ratio of the Value added (in %) in Textiles and clothing in 2006 to that in 2009?
Provide a succinct answer. 0.9. What is the ratio of the Value added (in %) in Machinery in 2006 to that in 2010?
Give a very brief answer. 0.84. What is the ratio of the Value added (in %) of Transport equipments in 2006 to that in 2010?
Keep it short and to the point. 0.88. What is the ratio of the Value added (in %) in Textiles and clothing in 2006 to that in 2010?
Make the answer very short. 0.9. What is the ratio of the Value added (in %) in Machinery in 2007 to that in 2008?
Make the answer very short. 1.06. What is the ratio of the Value added (in %) in Transport equipments in 2007 to that in 2008?
Offer a terse response. 0.97. What is the ratio of the Value added (in %) in Textiles and clothing in 2007 to that in 2008?
Your response must be concise. 1.06. What is the ratio of the Value added (in %) of Machinery in 2007 to that in 2009?
Ensure brevity in your answer.  0.91. What is the ratio of the Value added (in %) in Transport equipments in 2007 to that in 2009?
Your answer should be very brief. 0.89. What is the ratio of the Value added (in %) in Textiles and clothing in 2007 to that in 2009?
Offer a terse response. 0.86. What is the ratio of the Value added (in %) in Machinery in 2007 to that in 2010?
Your response must be concise. 0.84. What is the ratio of the Value added (in %) of Transport equipments in 2007 to that in 2010?
Offer a terse response. 0.88. What is the ratio of the Value added (in %) in Textiles and clothing in 2007 to that in 2010?
Provide a short and direct response. 0.86. What is the ratio of the Value added (in %) in Machinery in 2008 to that in 2009?
Your answer should be very brief. 0.86. What is the ratio of the Value added (in %) of Transport equipments in 2008 to that in 2009?
Your answer should be compact. 0.92. What is the ratio of the Value added (in %) of Textiles and clothing in 2008 to that in 2009?
Offer a very short reply. 0.81. What is the ratio of the Value added (in %) of Machinery in 2008 to that in 2010?
Offer a terse response. 0.79. What is the ratio of the Value added (in %) of Transport equipments in 2008 to that in 2010?
Your response must be concise. 0.91. What is the ratio of the Value added (in %) in Textiles and clothing in 2008 to that in 2010?
Give a very brief answer. 0.81. What is the ratio of the Value added (in %) of Machinery in 2009 to that in 2010?
Your answer should be very brief. 0.92. What is the difference between the highest and the second highest Value added (in %) in Machinery?
Give a very brief answer. 0.95. What is the difference between the highest and the second highest Value added (in %) in Transport equipments?
Your answer should be compact. 0.25. What is the difference between the highest and the second highest Value added (in %) of Textiles and clothing?
Offer a terse response. 3.26. What is the difference between the highest and the lowest Value added (in %) of Machinery?
Provide a short and direct response. 5.66. What is the difference between the highest and the lowest Value added (in %) of Transport equipments?
Provide a succinct answer. 11.58. What is the difference between the highest and the lowest Value added (in %) of Textiles and clothing?
Make the answer very short. 4.04. 